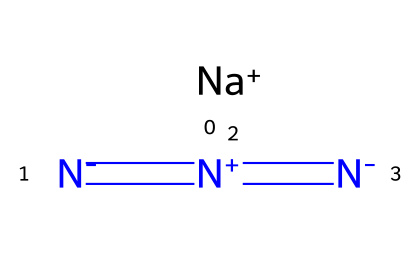What is the chemical name of this compound? The SMILES representation suggests the presence of sodium (Na) and a chain of nitrogen atoms (N), which is characteristic of azides. Therefore, this compound is Sodium Azide.
Answer: Sodium Azide How many nitrogen atoms are present in the structure? By examining the SMILES notation, we observe a sequence of nitrogen atoms connected by double bonds. There are a total of three nitrogen atoms in the structure.
Answer: 3 What type of bonding is primarily present between the nitrogen atoms? The SMILES representation indicates double bonding between the nitrogen atoms, as denoted by the "=" symbol. This indicates that the nitrogen atoms are connected by double bonds.
Answer: Double bonds What charge does sodium carry in this compound? In the SMILES, the sodium ion is denoted by [Na+], indicating that it has a positive charge. This is a characteristic feature of ionic compounds.
Answer: Positive charge What is the overall charge of the azide ion present in the compound? The azide ion consists of three nitrogen atoms arranged in a particular manner. Each nitrogen atom connects with bonds, leading to an overall negative charge on the azide ion, as indicated in the structure.
Answer: Negative charge Why is sodium azide used in car airbags? Sodium azide rapidly decomposes upon ignition, producing nitrogen gas, which quickly inflates the airbag in a safe and efficient manner, making it suitable for automotive safety applications.
Answer: Rapid nitrogen production Is sodium azide a solid at room temperature? Based on its properties as an azide and general knowledge of sodium azide, it exists as a solid at room temperature, further confirmed by its usage in airbag systems.
Answer: Yes 